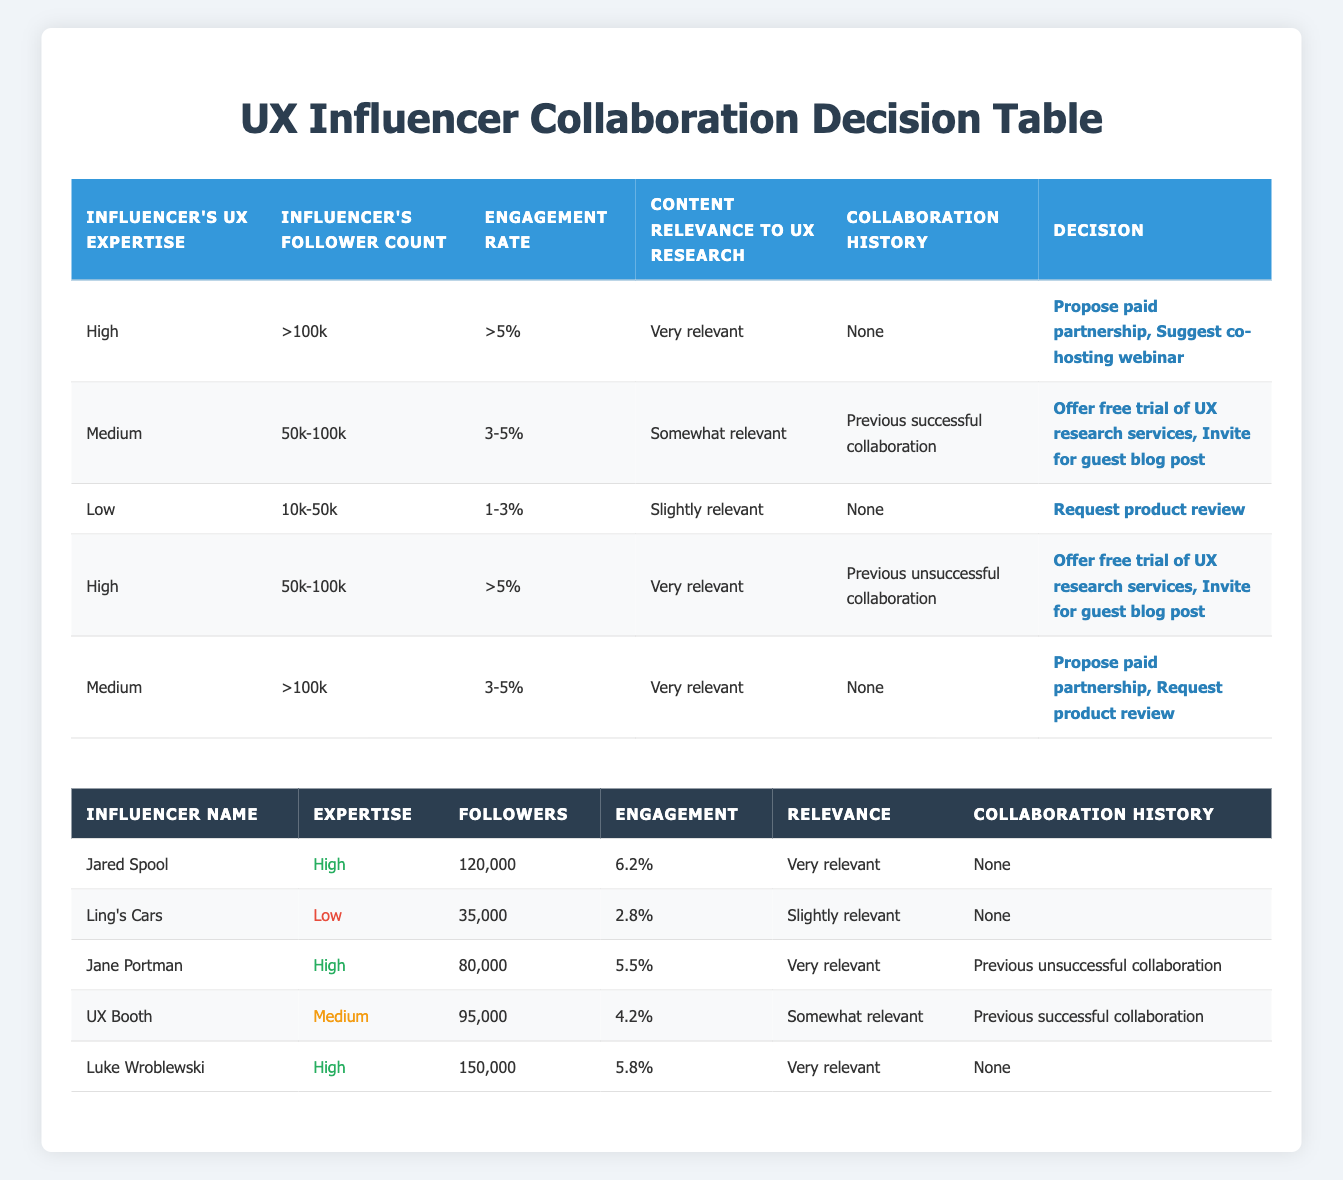What influencer has the highest follower count? The table lists the followers for each influencer. By comparing the values, Luke Wroblewski has 150,000 followers, which is the highest among all listed influencers.
Answer: Luke Wroblewski How many influencers have a "High" level of UX expertise? The table includes a count of influencers with a "High" expertise level. There are three influencers: Jared Spool, Jane Portman, and Luke Wroblewski.
Answer: 3 Is there any influencer with a "Low" level of UX expertise who has a "None" collaboration history? By examining the table, Ling's Cars is the only influencer with "Low" expertise and "None" for collaboration history.
Answer: Yes What is the average engagement rate of the influencers with "High" UX expertise? First, we gather the engagement rates of the three influencers with "High" expertise (Jared Spool: 6.2%, Jane Portman: 5.5%, Luke Wroblewski: 5.8%). Adding these gives: 6.2 + 5.5 + 5.8 = 17.5. Then, divide by the number of influencers (3): 17.5 / 3 = 5.83. The average engagement rate is 5.83%.
Answer: 5.83% Which influencers can we consider for a paid partnership? To identify influencers suitable for a paid partnership, we look for those with "High" UX expertise, more than 100k followers, and an engagement rate greater than 5%. Jared Spool matches both high expertise and follower count, while Luke Wroblewski qualifies as well.
Answer: Jared Spool, Luke Wroblewski What action should be taken for an influencer with a follower count between 50k and 100k and previous successful collaboration history? The table lists the conditions for influencers fitting this description as Medium expertise, 50k-100k followers, and having successful collaborations. The suggested actions for this category are to offer a free trial of UX research services or invite them for a guest blog post.
Answer: Offer free trial of UX research services, Invite for guest blog post Are there any influencers with previous unsuccessful collaboration who have a "High" level of UX expertise? By scanning the table, we can see that Jane Portman has a "High" expertise level and falls under the category of previous unsuccessful collaborations.
Answer: Yes Which influencer would you recommend to request a product review? Analyzing the table, the conditions for requesting a product review suggest that the influencer should have "Low" expertise, follower count between 10k and 50k, an engagement rate of 1-3%, and none for collaboration history. The only influencer meeting these criteria is Ling's Cars.
Answer: Ling's Cars 